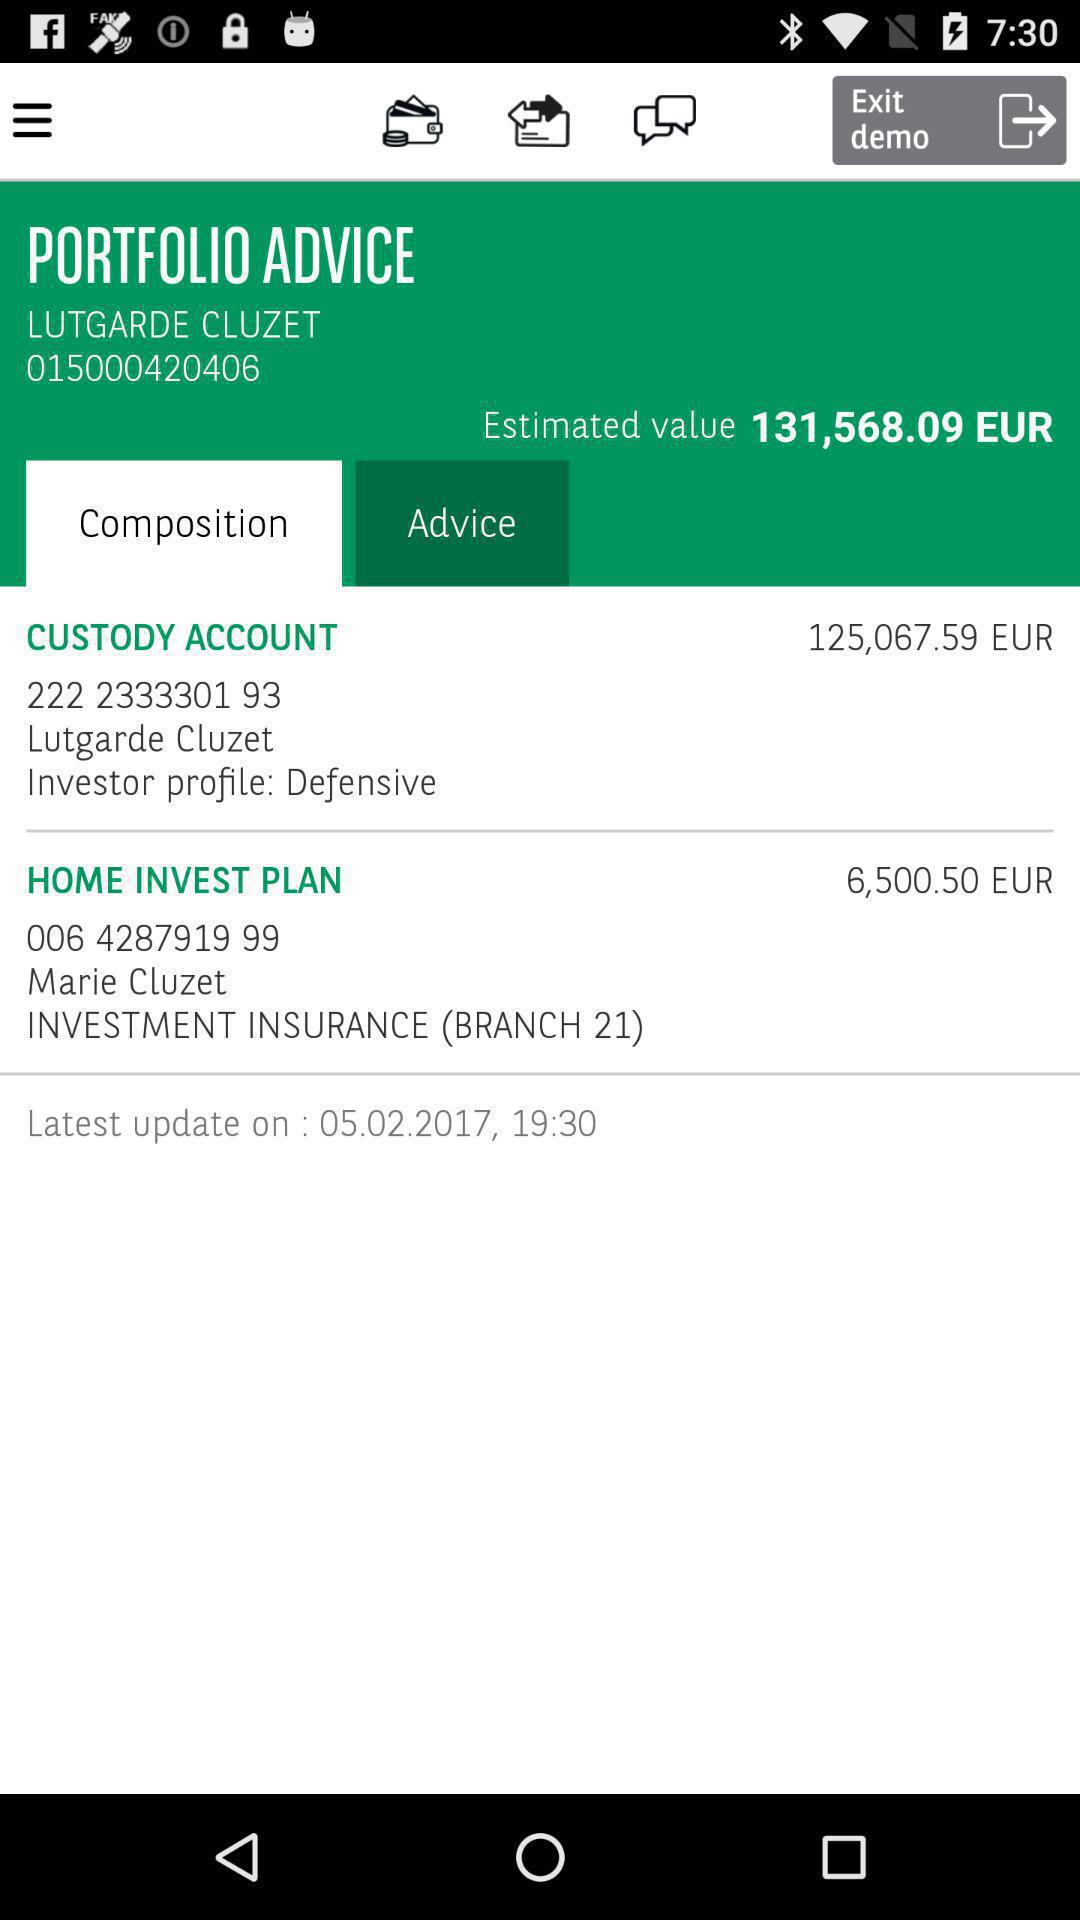What is the price in the custody account? The price is €125,067.59 (EUR). 